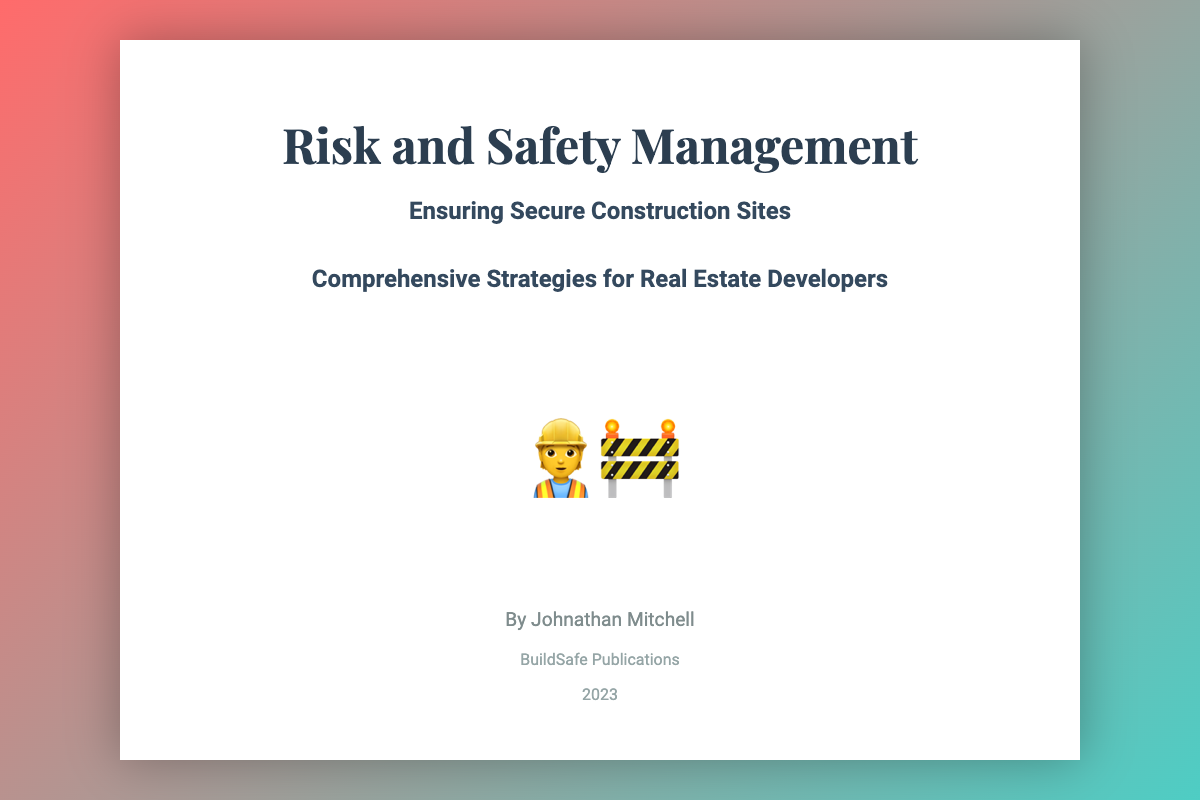What is the title of the book? The title is prominently displayed at the top of the cover.
Answer: Risk and Safety Management Who is the author of the book? The author's name is listed beneath the title and subtitle.
Answer: Johnathan Mitchell What is the subtitle of the book? The subtitle provides additional context about the book's focus.
Answer: Ensuring Secure Construction Sites What year was the book published? The publication year is found at the bottom of the cover.
Answer: 2023 What is the name of the publisher? The publisher's name is also displayed at the bottom of the cover.
Answer: BuildSafe Publications What is the main theme of the book cover? The visual and textual elements convey the subject of construction safety.
Answer: Secure Construction Sites How many subtitles are there on the cover? The cover features a main subtitle and an additional descriptive subtitle.
Answer: Two What color scheme is used on the book cover? The background gradient consists of specific colors that enhance visibility.
Answer: Red and teal What size is the title compared to the author’s name? The title is displayed in a larger font size to emphasize its importance.
Answer: Larger 